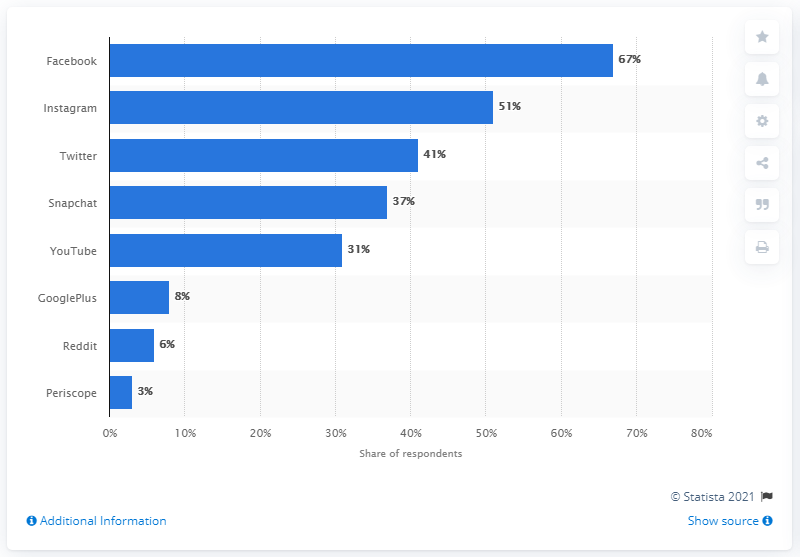Outline some significant characteristics in this image. According to the results of the survey, 67% of the respondents stated that they planned to use Facebook to stay informed about the Rio Games. 